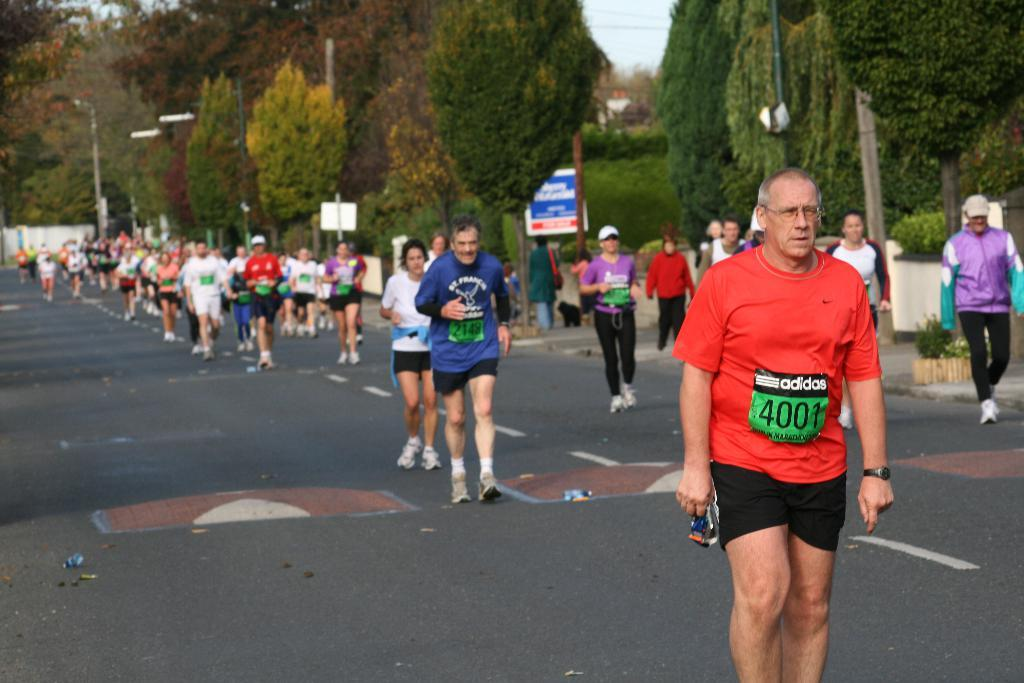How many people are in the image? There are people in the image, but the exact number is not specified. What is the main feature of the image? The main features of the image include a road, poles, boards, a wall, plants, trees, and the sky in the background. What type of structures can be seen in the image? The structures in the image include poles, boards, and a wall. What type of vegetation is present in the image? The vegetation in the image includes plants and trees. What is visible in the background of the image? The sky is visible in the background of the image. What type of skirt is the tree wearing in the image? There are no trees wearing skirts in the image; trees are plants and do not wear clothing. 